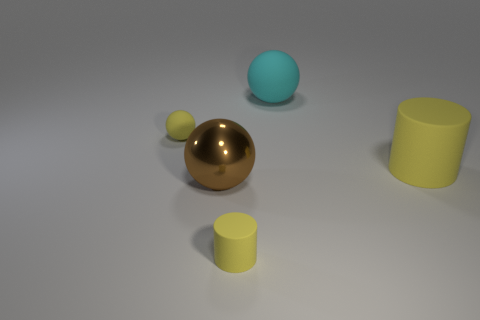Is there anything else that is the same material as the large brown thing?
Ensure brevity in your answer.  No. Do the big rubber cylinder and the tiny matte thing behind the tiny yellow rubber cylinder have the same color?
Keep it short and to the point. Yes. Are there any red balls that have the same size as the yellow ball?
Give a very brief answer. No. There is a cylinder behind the shiny object; how big is it?
Provide a succinct answer. Large. There is a tiny yellow thing that is in front of the big yellow cylinder; is there a large metallic sphere that is right of it?
Ensure brevity in your answer.  No. How many other things are there of the same shape as the cyan object?
Your answer should be compact. 2. Do the large brown thing and the big yellow rubber object have the same shape?
Provide a short and direct response. No. What is the color of the big thing that is in front of the big cyan object and to the left of the large yellow thing?
Provide a short and direct response. Brown. The sphere that is the same color as the tiny matte cylinder is what size?
Offer a very short reply. Small. What number of large things are either yellow cylinders or red metal blocks?
Offer a terse response. 1. 